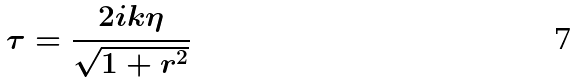<formula> <loc_0><loc_0><loc_500><loc_500>\tau = \frac { 2 i k \eta } { \sqrt { 1 + r ^ { 2 } } }</formula> 